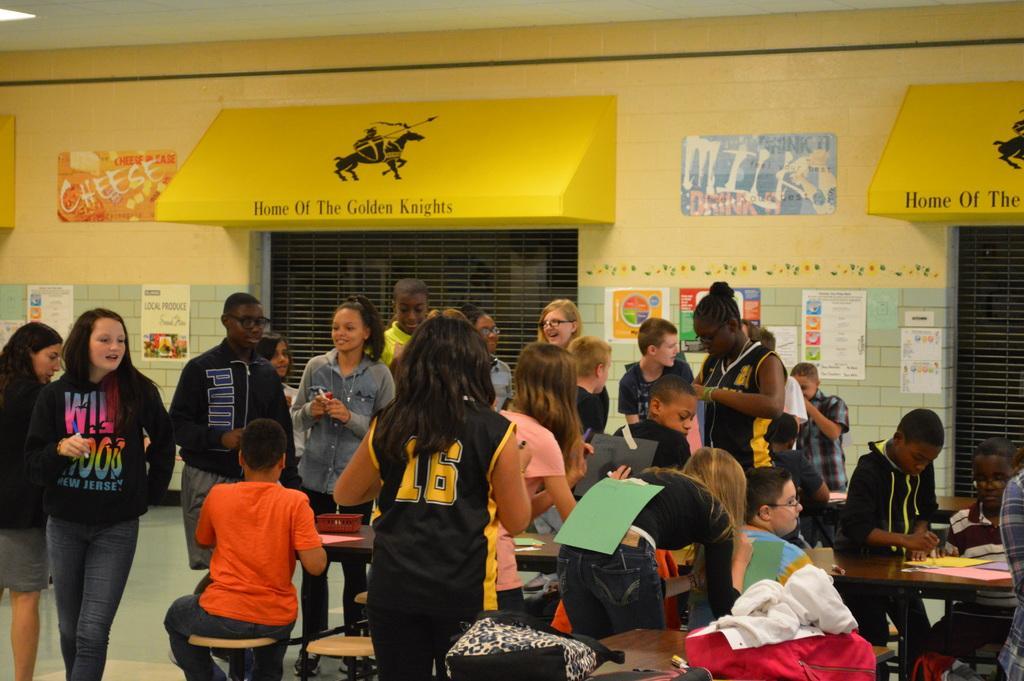In one or two sentences, can you explain what this image depicts? Here we can see people. Few are sitting. On these tables there are papers and object. Posters are on the wall. These are grills. 